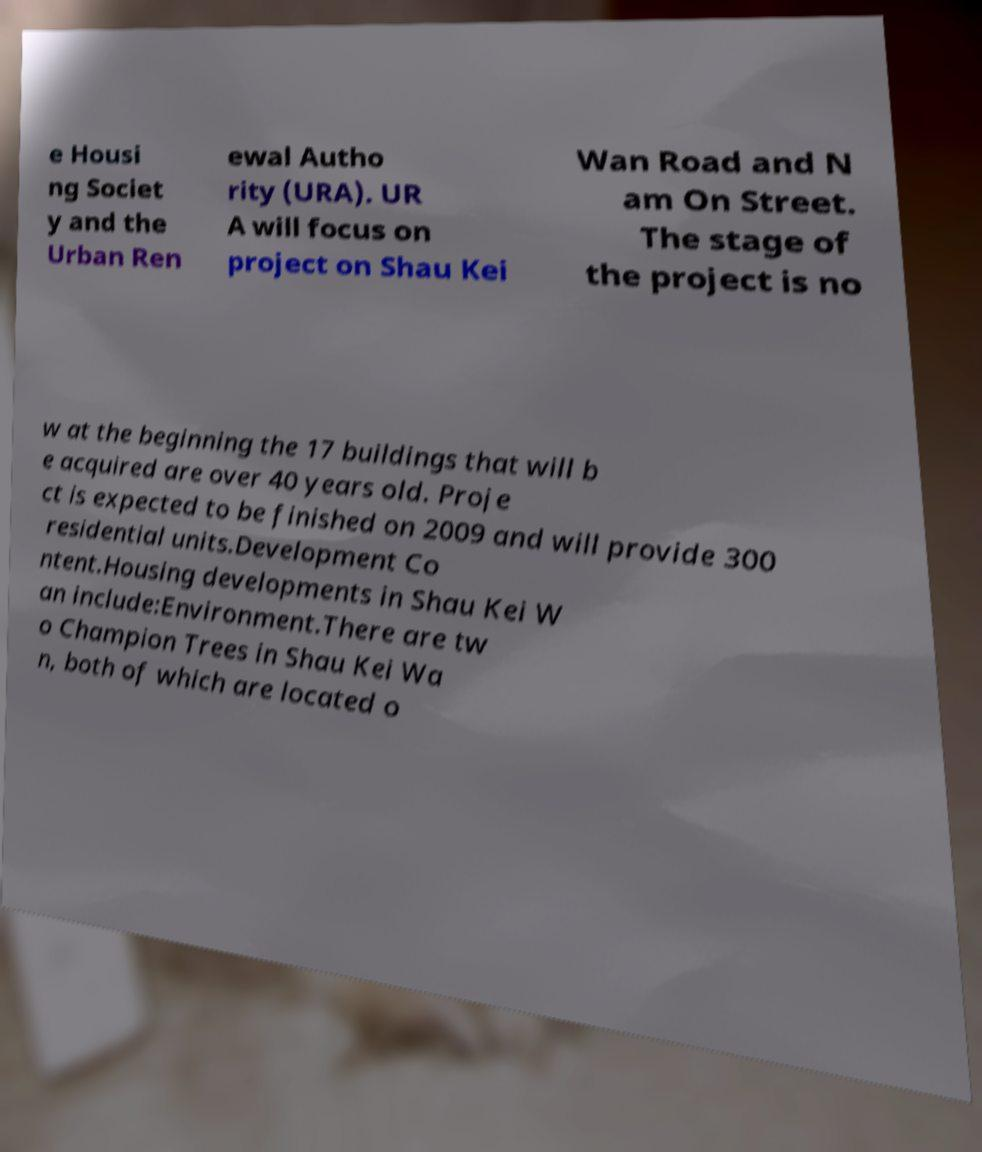Can you accurately transcribe the text from the provided image for me? e Housi ng Societ y and the Urban Ren ewal Autho rity (URA). UR A will focus on project on Shau Kei Wan Road and N am On Street. The stage of the project is no w at the beginning the 17 buildings that will b e acquired are over 40 years old. Proje ct is expected to be finished on 2009 and will provide 300 residential units.Development Co ntent.Housing developments in Shau Kei W an include:Environment.There are tw o Champion Trees in Shau Kei Wa n, both of which are located o 